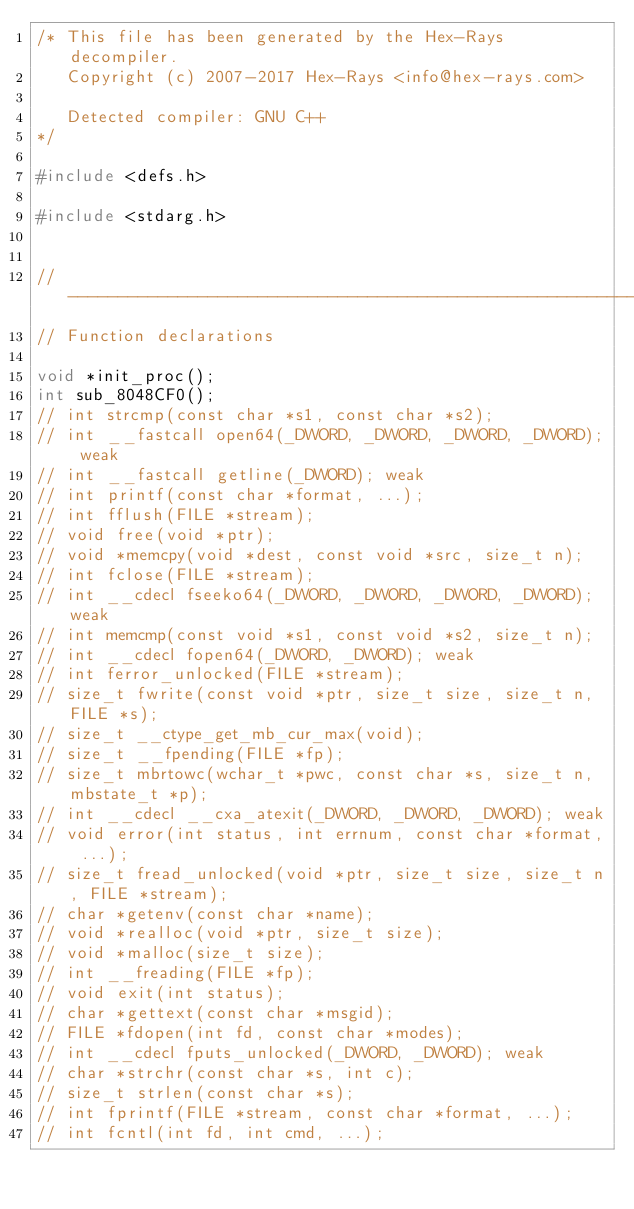<code> <loc_0><loc_0><loc_500><loc_500><_C_>/* This file has been generated by the Hex-Rays decompiler.
   Copyright (c) 2007-2017 Hex-Rays <info@hex-rays.com>

   Detected compiler: GNU C++
*/

#include <defs.h>

#include <stdarg.h>


//-------------------------------------------------------------------------
// Function declarations

void *init_proc();
int sub_8048CF0();
// int strcmp(const char *s1, const char *s2);
// int __fastcall open64(_DWORD, _DWORD, _DWORD, _DWORD); weak
// int __fastcall getline(_DWORD); weak
// int printf(const char *format, ...);
// int fflush(FILE *stream);
// void free(void *ptr);
// void *memcpy(void *dest, const void *src, size_t n);
// int fclose(FILE *stream);
// int __cdecl fseeko64(_DWORD, _DWORD, _DWORD, _DWORD); weak
// int memcmp(const void *s1, const void *s2, size_t n);
// int __cdecl fopen64(_DWORD, _DWORD); weak
// int ferror_unlocked(FILE *stream);
// size_t fwrite(const void *ptr, size_t size, size_t n, FILE *s);
// size_t __ctype_get_mb_cur_max(void);
// size_t __fpending(FILE *fp);
// size_t mbrtowc(wchar_t *pwc, const char *s, size_t n, mbstate_t *p);
// int __cdecl __cxa_atexit(_DWORD, _DWORD, _DWORD); weak
// void error(int status, int errnum, const char *format, ...);
// size_t fread_unlocked(void *ptr, size_t size, size_t n, FILE *stream);
// char *getenv(const char *name);
// void *realloc(void *ptr, size_t size);
// void *malloc(size_t size);
// int __freading(FILE *fp);
// void exit(int status);
// char *gettext(const char *msgid);
// FILE *fdopen(int fd, const char *modes);
// int __cdecl fputs_unlocked(_DWORD, _DWORD); weak
// char *strchr(const char *s, int c);
// size_t strlen(const char *s);
// int fprintf(FILE *stream, const char *format, ...);
// int fcntl(int fd, int cmd, ...);</code> 